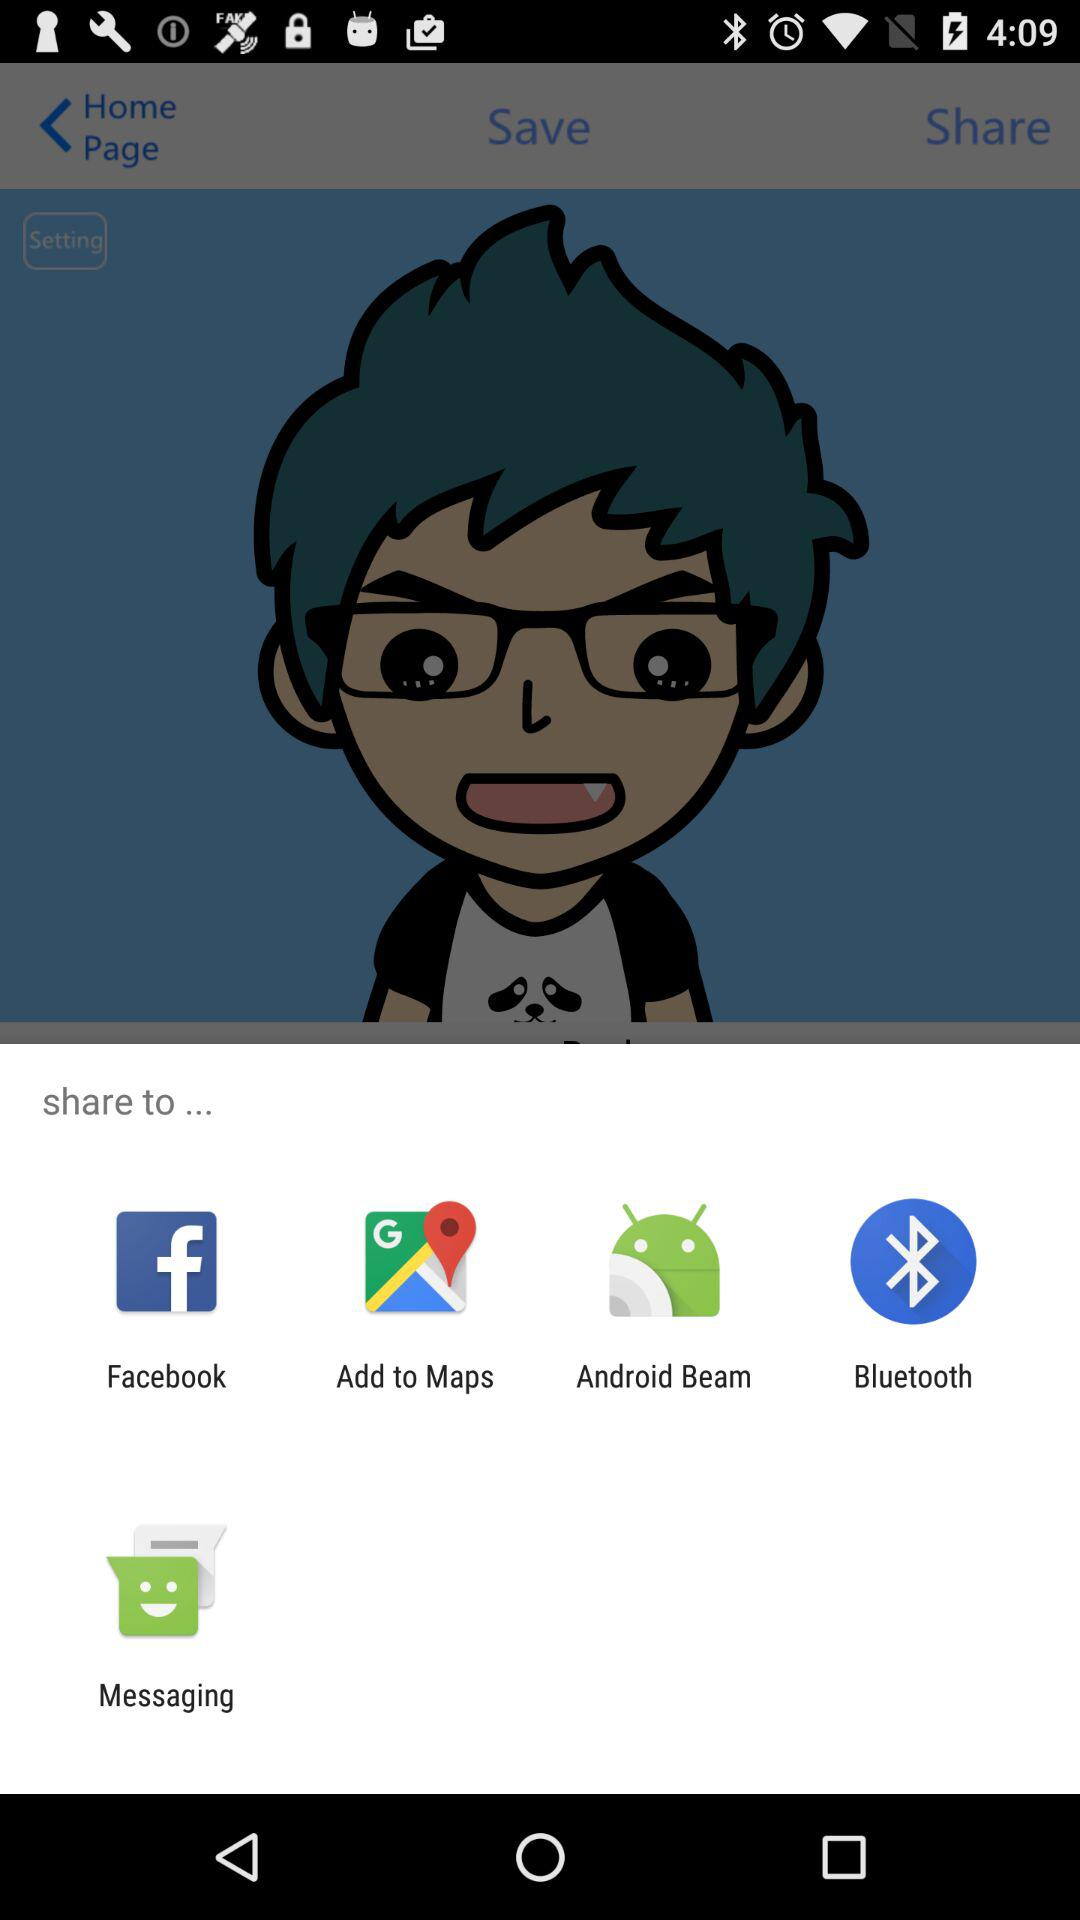Which app can we use to share? You can use "Facebook", "Add to Maps", "Android Beam", "Bluetooth" and "Messaging" to share. 